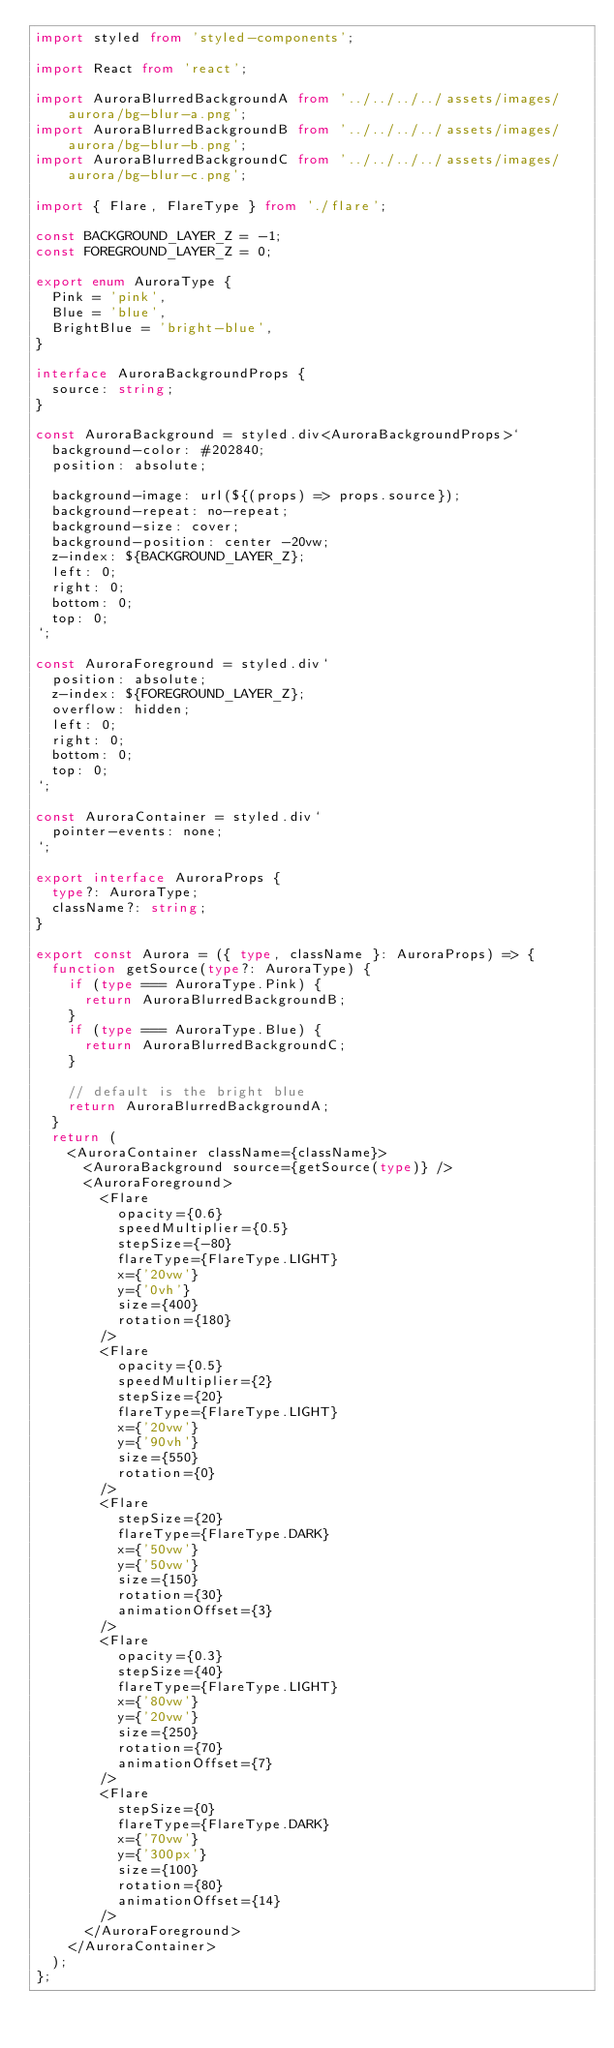Convert code to text. <code><loc_0><loc_0><loc_500><loc_500><_TypeScript_>import styled from 'styled-components';

import React from 'react';

import AuroraBlurredBackgroundA from '../../../../assets/images/aurora/bg-blur-a.png';
import AuroraBlurredBackgroundB from '../../../../assets/images/aurora/bg-blur-b.png';
import AuroraBlurredBackgroundC from '../../../../assets/images/aurora/bg-blur-c.png';

import { Flare, FlareType } from './flare';

const BACKGROUND_LAYER_Z = -1;
const FOREGROUND_LAYER_Z = 0;

export enum AuroraType {
  Pink = 'pink',
  Blue = 'blue',
  BrightBlue = 'bright-blue',
}

interface AuroraBackgroundProps {
  source: string;
}

const AuroraBackground = styled.div<AuroraBackgroundProps>`
  background-color: #202840;
  position: absolute;

  background-image: url(${(props) => props.source});
  background-repeat: no-repeat;
  background-size: cover;
  background-position: center -20vw;
  z-index: ${BACKGROUND_LAYER_Z};
  left: 0;
  right: 0;
  bottom: 0;
  top: 0;
`;

const AuroraForeground = styled.div`
  position: absolute;
  z-index: ${FOREGROUND_LAYER_Z};
  overflow: hidden;
  left: 0;
  right: 0;
  bottom: 0;
  top: 0;
`;

const AuroraContainer = styled.div`
  pointer-events: none;
`;

export interface AuroraProps {
  type?: AuroraType;
  className?: string;
}

export const Aurora = ({ type, className }: AuroraProps) => {
  function getSource(type?: AuroraType) {
    if (type === AuroraType.Pink) {
      return AuroraBlurredBackgroundB;
    }
    if (type === AuroraType.Blue) {
      return AuroraBlurredBackgroundC;
    }

    // default is the bright blue
    return AuroraBlurredBackgroundA;
  }
  return (
    <AuroraContainer className={className}>
      <AuroraBackground source={getSource(type)} />
      <AuroraForeground>
        <Flare
          opacity={0.6}
          speedMultiplier={0.5}
          stepSize={-80}
          flareType={FlareType.LIGHT}
          x={'20vw'}
          y={'0vh'}
          size={400}
          rotation={180}
        />
        <Flare
          opacity={0.5}
          speedMultiplier={2}
          stepSize={20}
          flareType={FlareType.LIGHT}
          x={'20vw'}
          y={'90vh'}
          size={550}
          rotation={0}
        />
        <Flare
          stepSize={20}
          flareType={FlareType.DARK}
          x={'50vw'}
          y={'50vw'}
          size={150}
          rotation={30}
          animationOffset={3}
        />
        <Flare
          opacity={0.3}
          stepSize={40}
          flareType={FlareType.LIGHT}
          x={'80vw'}
          y={'20vw'}
          size={250}
          rotation={70}
          animationOffset={7}
        />
        <Flare
          stepSize={0}
          flareType={FlareType.DARK}
          x={'70vw'}
          y={'300px'}
          size={100}
          rotation={80}
          animationOffset={14}
        />
      </AuroraForeground>
    </AuroraContainer>
  );
};
</code> 